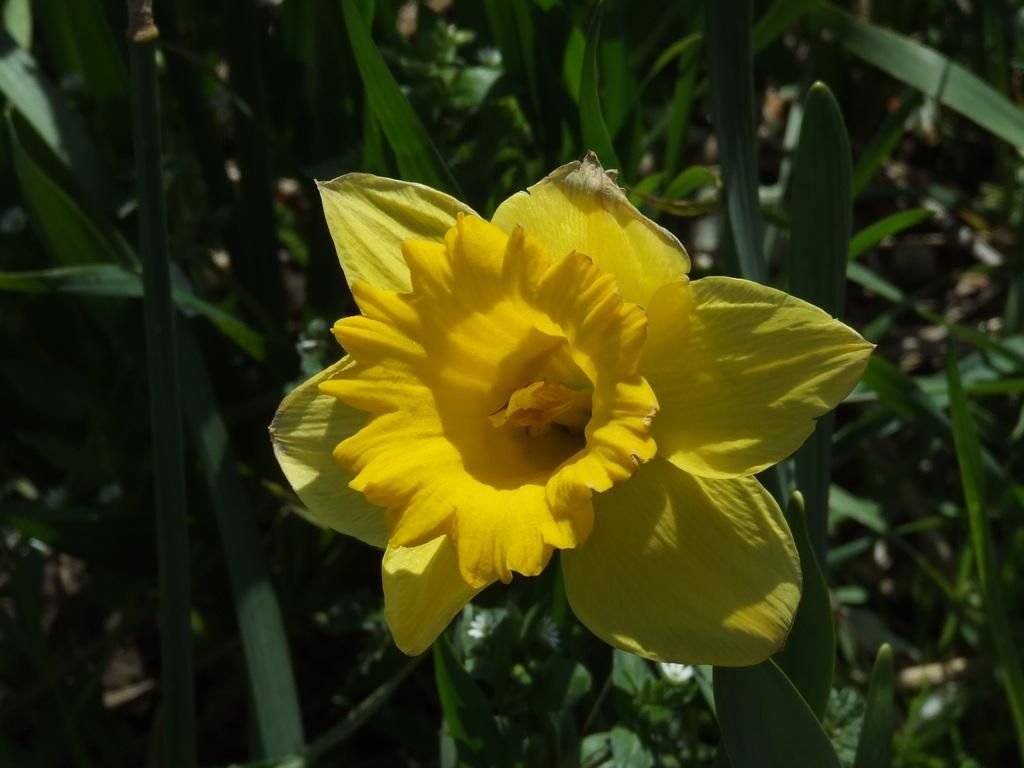What is the main subject of the image? There is a flower in the image. Can you describe the color of the flower? The flower is yellow. What can be seen in the background of the image? There are trees or plants in the background of the image. How is the background of the image depicted? The background of the image is blurred. Can you tell me how much the library charges for a sneeze in the image? There is no library or mention of a sneeze in the image; it features a yellow flower with a blurred background. 